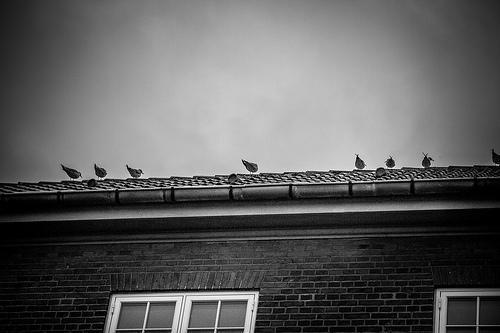How many birds are pictured?
Give a very brief answer. 8. How many window slots are shown?
Give a very brief answer. 2. 